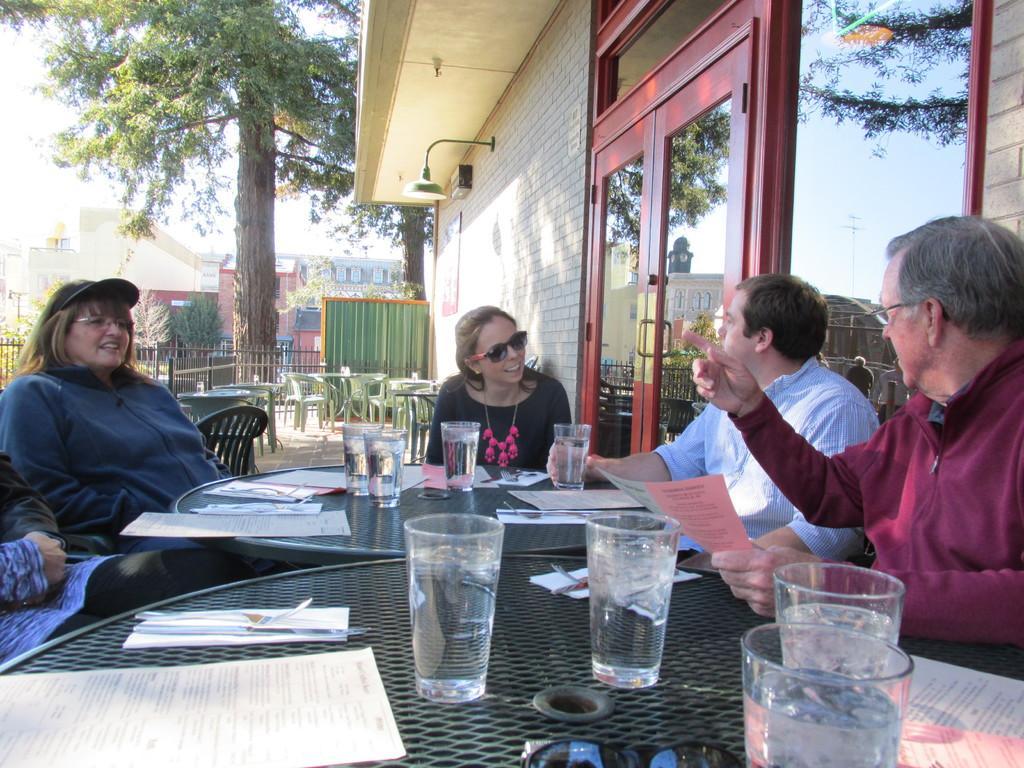Can you describe this image briefly? In the image we can see four persons were sitting on the chair around the table,on table we can see some objects like glasses,paper etc. Coming to the background we can see the building,trees and sky and empty chairs. 